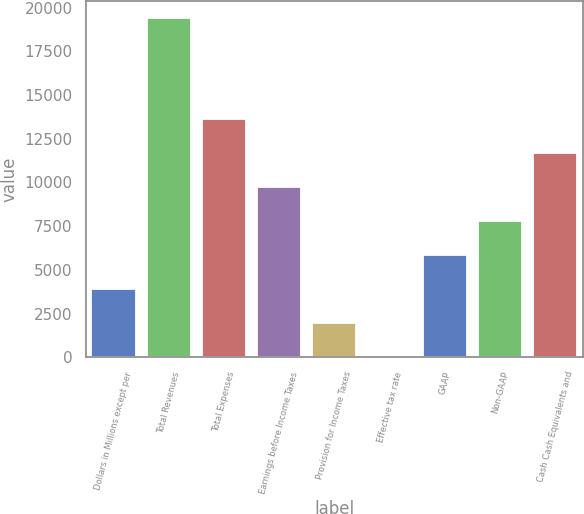Convert chart. <chart><loc_0><loc_0><loc_500><loc_500><bar_chart><fcel>Dollars in Millions except per<fcel>Total Revenues<fcel>Total Expenses<fcel>Earnings before Income Taxes<fcel>Provision for Income Taxes<fcel>Effective tax rate<fcel>GAAP<fcel>Non-GAAP<fcel>Cash Cash Equivalents and<nl><fcel>3904.44<fcel>19427<fcel>13606<fcel>9725.4<fcel>1964.12<fcel>23.8<fcel>5844.76<fcel>7785.08<fcel>11665.7<nl></chart> 